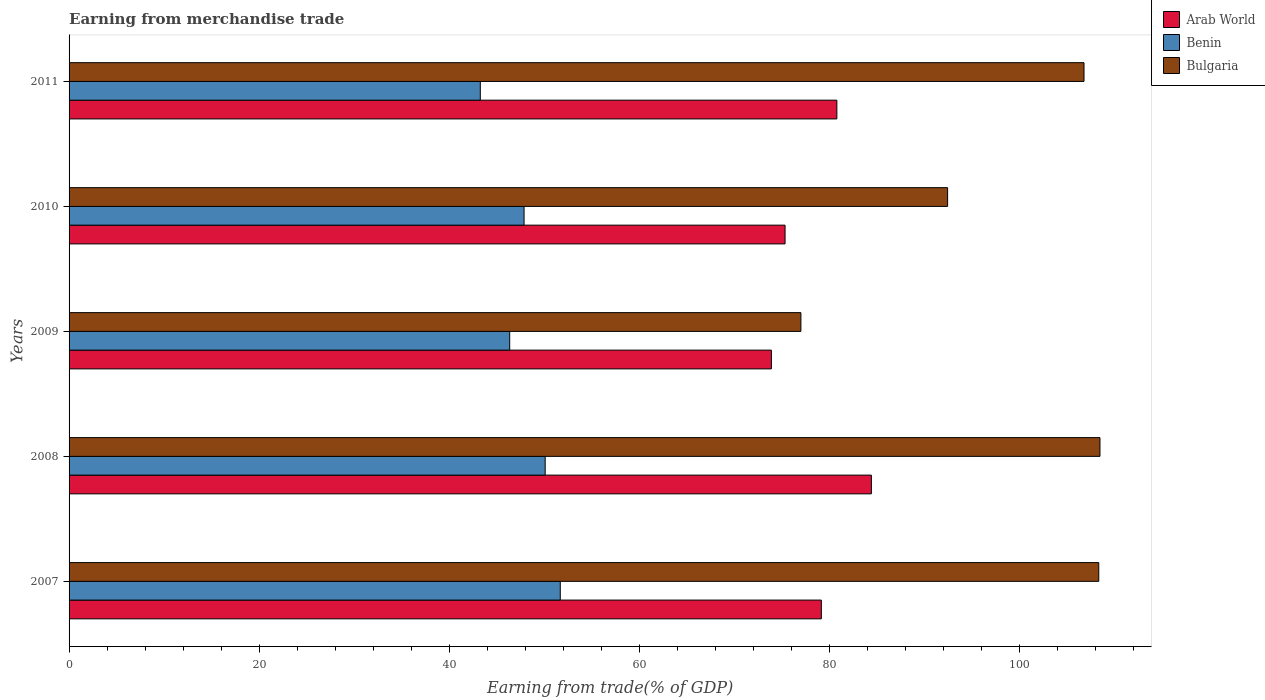How many different coloured bars are there?
Your answer should be compact. 3. How many groups of bars are there?
Offer a very short reply. 5. Are the number of bars per tick equal to the number of legend labels?
Make the answer very short. Yes. Are the number of bars on each tick of the Y-axis equal?
Provide a short and direct response. Yes. What is the label of the 5th group of bars from the top?
Your answer should be very brief. 2007. What is the earnings from trade in Bulgaria in 2010?
Offer a terse response. 92.4. Across all years, what is the maximum earnings from trade in Benin?
Your answer should be compact. 51.66. Across all years, what is the minimum earnings from trade in Arab World?
Offer a terse response. 73.86. What is the total earnings from trade in Benin in the graph?
Your answer should be very brief. 239.18. What is the difference between the earnings from trade in Benin in 2007 and that in 2010?
Make the answer very short. 3.81. What is the difference between the earnings from trade in Benin in 2009 and the earnings from trade in Bulgaria in 2011?
Make the answer very short. -60.4. What is the average earnings from trade in Benin per year?
Offer a very short reply. 47.84. In the year 2011, what is the difference between the earnings from trade in Bulgaria and earnings from trade in Benin?
Provide a succinct answer. 63.49. What is the ratio of the earnings from trade in Bulgaria in 2007 to that in 2009?
Offer a terse response. 1.41. What is the difference between the highest and the second highest earnings from trade in Bulgaria?
Make the answer very short. 0.13. What is the difference between the highest and the lowest earnings from trade in Arab World?
Give a very brief answer. 10.51. Is the sum of the earnings from trade in Bulgaria in 2007 and 2009 greater than the maximum earnings from trade in Arab World across all years?
Make the answer very short. Yes. What does the 1st bar from the top in 2008 represents?
Keep it short and to the point. Bulgaria. What does the 2nd bar from the bottom in 2010 represents?
Keep it short and to the point. Benin. Is it the case that in every year, the sum of the earnings from trade in Benin and earnings from trade in Arab World is greater than the earnings from trade in Bulgaria?
Your response must be concise. Yes. Are all the bars in the graph horizontal?
Ensure brevity in your answer.  Yes. How many years are there in the graph?
Offer a very short reply. 5. Are the values on the major ticks of X-axis written in scientific E-notation?
Provide a short and direct response. No. Does the graph contain grids?
Keep it short and to the point. No. Where does the legend appear in the graph?
Provide a succinct answer. Top right. How are the legend labels stacked?
Your answer should be compact. Vertical. What is the title of the graph?
Ensure brevity in your answer.  Earning from merchandise trade. Does "Middle East & North Africa (all income levels)" appear as one of the legend labels in the graph?
Provide a succinct answer. No. What is the label or title of the X-axis?
Make the answer very short. Earning from trade(% of GDP). What is the Earning from trade(% of GDP) of Arab World in 2007?
Provide a short and direct response. 79.12. What is the Earning from trade(% of GDP) of Benin in 2007?
Offer a terse response. 51.66. What is the Earning from trade(% of GDP) of Bulgaria in 2007?
Ensure brevity in your answer.  108.3. What is the Earning from trade(% of GDP) in Arab World in 2008?
Offer a very short reply. 84.38. What is the Earning from trade(% of GDP) in Benin in 2008?
Ensure brevity in your answer.  50.07. What is the Earning from trade(% of GDP) of Bulgaria in 2008?
Offer a terse response. 108.42. What is the Earning from trade(% of GDP) in Arab World in 2009?
Make the answer very short. 73.86. What is the Earning from trade(% of GDP) in Benin in 2009?
Provide a short and direct response. 46.34. What is the Earning from trade(% of GDP) in Bulgaria in 2009?
Offer a terse response. 76.97. What is the Earning from trade(% of GDP) in Arab World in 2010?
Your response must be concise. 75.3. What is the Earning from trade(% of GDP) of Benin in 2010?
Keep it short and to the point. 47.85. What is the Earning from trade(% of GDP) of Bulgaria in 2010?
Your answer should be compact. 92.4. What is the Earning from trade(% of GDP) in Arab World in 2011?
Ensure brevity in your answer.  80.75. What is the Earning from trade(% of GDP) of Benin in 2011?
Your answer should be very brief. 43.25. What is the Earning from trade(% of GDP) in Bulgaria in 2011?
Your response must be concise. 106.74. Across all years, what is the maximum Earning from trade(% of GDP) in Arab World?
Give a very brief answer. 84.38. Across all years, what is the maximum Earning from trade(% of GDP) of Benin?
Give a very brief answer. 51.66. Across all years, what is the maximum Earning from trade(% of GDP) of Bulgaria?
Provide a short and direct response. 108.42. Across all years, what is the minimum Earning from trade(% of GDP) of Arab World?
Provide a succinct answer. 73.86. Across all years, what is the minimum Earning from trade(% of GDP) of Benin?
Your response must be concise. 43.25. Across all years, what is the minimum Earning from trade(% of GDP) in Bulgaria?
Provide a short and direct response. 76.97. What is the total Earning from trade(% of GDP) of Arab World in the graph?
Provide a succinct answer. 393.41. What is the total Earning from trade(% of GDP) of Benin in the graph?
Offer a terse response. 239.18. What is the total Earning from trade(% of GDP) in Bulgaria in the graph?
Give a very brief answer. 492.83. What is the difference between the Earning from trade(% of GDP) of Arab World in 2007 and that in 2008?
Your response must be concise. -5.26. What is the difference between the Earning from trade(% of GDP) in Benin in 2007 and that in 2008?
Make the answer very short. 1.59. What is the difference between the Earning from trade(% of GDP) in Bulgaria in 2007 and that in 2008?
Your response must be concise. -0.13. What is the difference between the Earning from trade(% of GDP) of Arab World in 2007 and that in 2009?
Offer a very short reply. 5.25. What is the difference between the Earning from trade(% of GDP) in Benin in 2007 and that in 2009?
Your answer should be very brief. 5.32. What is the difference between the Earning from trade(% of GDP) of Bulgaria in 2007 and that in 2009?
Provide a succinct answer. 31.33. What is the difference between the Earning from trade(% of GDP) in Arab World in 2007 and that in 2010?
Offer a terse response. 3.81. What is the difference between the Earning from trade(% of GDP) of Benin in 2007 and that in 2010?
Make the answer very short. 3.81. What is the difference between the Earning from trade(% of GDP) of Bulgaria in 2007 and that in 2010?
Keep it short and to the point. 15.9. What is the difference between the Earning from trade(% of GDP) in Arab World in 2007 and that in 2011?
Provide a short and direct response. -1.63. What is the difference between the Earning from trade(% of GDP) in Benin in 2007 and that in 2011?
Keep it short and to the point. 8.41. What is the difference between the Earning from trade(% of GDP) in Bulgaria in 2007 and that in 2011?
Offer a terse response. 1.55. What is the difference between the Earning from trade(% of GDP) of Arab World in 2008 and that in 2009?
Give a very brief answer. 10.51. What is the difference between the Earning from trade(% of GDP) of Benin in 2008 and that in 2009?
Provide a succinct answer. 3.73. What is the difference between the Earning from trade(% of GDP) of Bulgaria in 2008 and that in 2009?
Your response must be concise. 31.45. What is the difference between the Earning from trade(% of GDP) of Arab World in 2008 and that in 2010?
Your answer should be very brief. 9.08. What is the difference between the Earning from trade(% of GDP) of Benin in 2008 and that in 2010?
Your answer should be very brief. 2.22. What is the difference between the Earning from trade(% of GDP) of Bulgaria in 2008 and that in 2010?
Provide a succinct answer. 16.02. What is the difference between the Earning from trade(% of GDP) of Arab World in 2008 and that in 2011?
Keep it short and to the point. 3.63. What is the difference between the Earning from trade(% of GDP) of Benin in 2008 and that in 2011?
Your response must be concise. 6.82. What is the difference between the Earning from trade(% of GDP) of Bulgaria in 2008 and that in 2011?
Ensure brevity in your answer.  1.68. What is the difference between the Earning from trade(% of GDP) of Arab World in 2009 and that in 2010?
Your answer should be compact. -1.44. What is the difference between the Earning from trade(% of GDP) in Benin in 2009 and that in 2010?
Make the answer very short. -1.51. What is the difference between the Earning from trade(% of GDP) of Bulgaria in 2009 and that in 2010?
Provide a succinct answer. -15.43. What is the difference between the Earning from trade(% of GDP) in Arab World in 2009 and that in 2011?
Offer a terse response. -6.89. What is the difference between the Earning from trade(% of GDP) in Benin in 2009 and that in 2011?
Make the answer very short. 3.09. What is the difference between the Earning from trade(% of GDP) in Bulgaria in 2009 and that in 2011?
Offer a terse response. -29.78. What is the difference between the Earning from trade(% of GDP) in Arab World in 2010 and that in 2011?
Your response must be concise. -5.45. What is the difference between the Earning from trade(% of GDP) of Benin in 2010 and that in 2011?
Your answer should be very brief. 4.6. What is the difference between the Earning from trade(% of GDP) of Bulgaria in 2010 and that in 2011?
Ensure brevity in your answer.  -14.35. What is the difference between the Earning from trade(% of GDP) in Arab World in 2007 and the Earning from trade(% of GDP) in Benin in 2008?
Your answer should be compact. 29.04. What is the difference between the Earning from trade(% of GDP) in Arab World in 2007 and the Earning from trade(% of GDP) in Bulgaria in 2008?
Provide a short and direct response. -29.3. What is the difference between the Earning from trade(% of GDP) in Benin in 2007 and the Earning from trade(% of GDP) in Bulgaria in 2008?
Provide a succinct answer. -56.76. What is the difference between the Earning from trade(% of GDP) of Arab World in 2007 and the Earning from trade(% of GDP) of Benin in 2009?
Provide a short and direct response. 32.78. What is the difference between the Earning from trade(% of GDP) in Arab World in 2007 and the Earning from trade(% of GDP) in Bulgaria in 2009?
Offer a very short reply. 2.15. What is the difference between the Earning from trade(% of GDP) of Benin in 2007 and the Earning from trade(% of GDP) of Bulgaria in 2009?
Keep it short and to the point. -25.31. What is the difference between the Earning from trade(% of GDP) in Arab World in 2007 and the Earning from trade(% of GDP) in Benin in 2010?
Keep it short and to the point. 31.26. What is the difference between the Earning from trade(% of GDP) of Arab World in 2007 and the Earning from trade(% of GDP) of Bulgaria in 2010?
Your answer should be compact. -13.28. What is the difference between the Earning from trade(% of GDP) in Benin in 2007 and the Earning from trade(% of GDP) in Bulgaria in 2010?
Provide a succinct answer. -40.74. What is the difference between the Earning from trade(% of GDP) in Arab World in 2007 and the Earning from trade(% of GDP) in Benin in 2011?
Offer a terse response. 35.87. What is the difference between the Earning from trade(% of GDP) in Arab World in 2007 and the Earning from trade(% of GDP) in Bulgaria in 2011?
Your answer should be compact. -27.63. What is the difference between the Earning from trade(% of GDP) of Benin in 2007 and the Earning from trade(% of GDP) of Bulgaria in 2011?
Give a very brief answer. -55.08. What is the difference between the Earning from trade(% of GDP) in Arab World in 2008 and the Earning from trade(% of GDP) in Benin in 2009?
Provide a succinct answer. 38.04. What is the difference between the Earning from trade(% of GDP) in Arab World in 2008 and the Earning from trade(% of GDP) in Bulgaria in 2009?
Make the answer very short. 7.41. What is the difference between the Earning from trade(% of GDP) in Benin in 2008 and the Earning from trade(% of GDP) in Bulgaria in 2009?
Provide a short and direct response. -26.9. What is the difference between the Earning from trade(% of GDP) in Arab World in 2008 and the Earning from trade(% of GDP) in Benin in 2010?
Your answer should be very brief. 36.53. What is the difference between the Earning from trade(% of GDP) of Arab World in 2008 and the Earning from trade(% of GDP) of Bulgaria in 2010?
Your answer should be compact. -8.02. What is the difference between the Earning from trade(% of GDP) of Benin in 2008 and the Earning from trade(% of GDP) of Bulgaria in 2010?
Your response must be concise. -42.33. What is the difference between the Earning from trade(% of GDP) in Arab World in 2008 and the Earning from trade(% of GDP) in Benin in 2011?
Provide a succinct answer. 41.13. What is the difference between the Earning from trade(% of GDP) in Arab World in 2008 and the Earning from trade(% of GDP) in Bulgaria in 2011?
Provide a succinct answer. -22.36. What is the difference between the Earning from trade(% of GDP) of Benin in 2008 and the Earning from trade(% of GDP) of Bulgaria in 2011?
Your response must be concise. -56.67. What is the difference between the Earning from trade(% of GDP) of Arab World in 2009 and the Earning from trade(% of GDP) of Benin in 2010?
Offer a terse response. 26.01. What is the difference between the Earning from trade(% of GDP) in Arab World in 2009 and the Earning from trade(% of GDP) in Bulgaria in 2010?
Your answer should be very brief. -18.53. What is the difference between the Earning from trade(% of GDP) of Benin in 2009 and the Earning from trade(% of GDP) of Bulgaria in 2010?
Offer a very short reply. -46.06. What is the difference between the Earning from trade(% of GDP) of Arab World in 2009 and the Earning from trade(% of GDP) of Benin in 2011?
Your answer should be very brief. 30.62. What is the difference between the Earning from trade(% of GDP) in Arab World in 2009 and the Earning from trade(% of GDP) in Bulgaria in 2011?
Provide a succinct answer. -32.88. What is the difference between the Earning from trade(% of GDP) of Benin in 2009 and the Earning from trade(% of GDP) of Bulgaria in 2011?
Ensure brevity in your answer.  -60.4. What is the difference between the Earning from trade(% of GDP) of Arab World in 2010 and the Earning from trade(% of GDP) of Benin in 2011?
Offer a very short reply. 32.05. What is the difference between the Earning from trade(% of GDP) in Arab World in 2010 and the Earning from trade(% of GDP) in Bulgaria in 2011?
Keep it short and to the point. -31.44. What is the difference between the Earning from trade(% of GDP) in Benin in 2010 and the Earning from trade(% of GDP) in Bulgaria in 2011?
Your answer should be very brief. -58.89. What is the average Earning from trade(% of GDP) in Arab World per year?
Provide a succinct answer. 78.68. What is the average Earning from trade(% of GDP) in Benin per year?
Keep it short and to the point. 47.84. What is the average Earning from trade(% of GDP) of Bulgaria per year?
Your answer should be very brief. 98.57. In the year 2007, what is the difference between the Earning from trade(% of GDP) in Arab World and Earning from trade(% of GDP) in Benin?
Offer a terse response. 27.46. In the year 2007, what is the difference between the Earning from trade(% of GDP) in Arab World and Earning from trade(% of GDP) in Bulgaria?
Ensure brevity in your answer.  -29.18. In the year 2007, what is the difference between the Earning from trade(% of GDP) of Benin and Earning from trade(% of GDP) of Bulgaria?
Give a very brief answer. -56.64. In the year 2008, what is the difference between the Earning from trade(% of GDP) of Arab World and Earning from trade(% of GDP) of Benin?
Offer a very short reply. 34.31. In the year 2008, what is the difference between the Earning from trade(% of GDP) of Arab World and Earning from trade(% of GDP) of Bulgaria?
Your answer should be compact. -24.04. In the year 2008, what is the difference between the Earning from trade(% of GDP) in Benin and Earning from trade(% of GDP) in Bulgaria?
Make the answer very short. -58.35. In the year 2009, what is the difference between the Earning from trade(% of GDP) in Arab World and Earning from trade(% of GDP) in Benin?
Your response must be concise. 27.52. In the year 2009, what is the difference between the Earning from trade(% of GDP) of Arab World and Earning from trade(% of GDP) of Bulgaria?
Offer a terse response. -3.1. In the year 2009, what is the difference between the Earning from trade(% of GDP) of Benin and Earning from trade(% of GDP) of Bulgaria?
Provide a succinct answer. -30.63. In the year 2010, what is the difference between the Earning from trade(% of GDP) of Arab World and Earning from trade(% of GDP) of Benin?
Keep it short and to the point. 27.45. In the year 2010, what is the difference between the Earning from trade(% of GDP) in Arab World and Earning from trade(% of GDP) in Bulgaria?
Provide a succinct answer. -17.1. In the year 2010, what is the difference between the Earning from trade(% of GDP) of Benin and Earning from trade(% of GDP) of Bulgaria?
Your answer should be compact. -44.55. In the year 2011, what is the difference between the Earning from trade(% of GDP) of Arab World and Earning from trade(% of GDP) of Benin?
Offer a very short reply. 37.5. In the year 2011, what is the difference between the Earning from trade(% of GDP) of Arab World and Earning from trade(% of GDP) of Bulgaria?
Offer a very short reply. -25.99. In the year 2011, what is the difference between the Earning from trade(% of GDP) of Benin and Earning from trade(% of GDP) of Bulgaria?
Provide a succinct answer. -63.49. What is the ratio of the Earning from trade(% of GDP) of Arab World in 2007 to that in 2008?
Your answer should be compact. 0.94. What is the ratio of the Earning from trade(% of GDP) of Benin in 2007 to that in 2008?
Provide a succinct answer. 1.03. What is the ratio of the Earning from trade(% of GDP) of Arab World in 2007 to that in 2009?
Keep it short and to the point. 1.07. What is the ratio of the Earning from trade(% of GDP) of Benin in 2007 to that in 2009?
Your response must be concise. 1.11. What is the ratio of the Earning from trade(% of GDP) in Bulgaria in 2007 to that in 2009?
Provide a succinct answer. 1.41. What is the ratio of the Earning from trade(% of GDP) of Arab World in 2007 to that in 2010?
Keep it short and to the point. 1.05. What is the ratio of the Earning from trade(% of GDP) in Benin in 2007 to that in 2010?
Ensure brevity in your answer.  1.08. What is the ratio of the Earning from trade(% of GDP) of Bulgaria in 2007 to that in 2010?
Ensure brevity in your answer.  1.17. What is the ratio of the Earning from trade(% of GDP) of Arab World in 2007 to that in 2011?
Your answer should be compact. 0.98. What is the ratio of the Earning from trade(% of GDP) in Benin in 2007 to that in 2011?
Make the answer very short. 1.19. What is the ratio of the Earning from trade(% of GDP) of Bulgaria in 2007 to that in 2011?
Your response must be concise. 1.01. What is the ratio of the Earning from trade(% of GDP) of Arab World in 2008 to that in 2009?
Offer a terse response. 1.14. What is the ratio of the Earning from trade(% of GDP) in Benin in 2008 to that in 2009?
Provide a succinct answer. 1.08. What is the ratio of the Earning from trade(% of GDP) of Bulgaria in 2008 to that in 2009?
Provide a short and direct response. 1.41. What is the ratio of the Earning from trade(% of GDP) of Arab World in 2008 to that in 2010?
Keep it short and to the point. 1.12. What is the ratio of the Earning from trade(% of GDP) of Benin in 2008 to that in 2010?
Keep it short and to the point. 1.05. What is the ratio of the Earning from trade(% of GDP) in Bulgaria in 2008 to that in 2010?
Provide a short and direct response. 1.17. What is the ratio of the Earning from trade(% of GDP) of Arab World in 2008 to that in 2011?
Make the answer very short. 1.04. What is the ratio of the Earning from trade(% of GDP) of Benin in 2008 to that in 2011?
Give a very brief answer. 1.16. What is the ratio of the Earning from trade(% of GDP) of Bulgaria in 2008 to that in 2011?
Keep it short and to the point. 1.02. What is the ratio of the Earning from trade(% of GDP) of Arab World in 2009 to that in 2010?
Keep it short and to the point. 0.98. What is the ratio of the Earning from trade(% of GDP) of Benin in 2009 to that in 2010?
Make the answer very short. 0.97. What is the ratio of the Earning from trade(% of GDP) of Bulgaria in 2009 to that in 2010?
Give a very brief answer. 0.83. What is the ratio of the Earning from trade(% of GDP) of Arab World in 2009 to that in 2011?
Keep it short and to the point. 0.91. What is the ratio of the Earning from trade(% of GDP) of Benin in 2009 to that in 2011?
Provide a short and direct response. 1.07. What is the ratio of the Earning from trade(% of GDP) of Bulgaria in 2009 to that in 2011?
Your answer should be very brief. 0.72. What is the ratio of the Earning from trade(% of GDP) of Arab World in 2010 to that in 2011?
Your answer should be very brief. 0.93. What is the ratio of the Earning from trade(% of GDP) in Benin in 2010 to that in 2011?
Provide a succinct answer. 1.11. What is the ratio of the Earning from trade(% of GDP) in Bulgaria in 2010 to that in 2011?
Ensure brevity in your answer.  0.87. What is the difference between the highest and the second highest Earning from trade(% of GDP) of Arab World?
Offer a very short reply. 3.63. What is the difference between the highest and the second highest Earning from trade(% of GDP) of Benin?
Give a very brief answer. 1.59. What is the difference between the highest and the second highest Earning from trade(% of GDP) of Bulgaria?
Give a very brief answer. 0.13. What is the difference between the highest and the lowest Earning from trade(% of GDP) in Arab World?
Your answer should be very brief. 10.51. What is the difference between the highest and the lowest Earning from trade(% of GDP) of Benin?
Offer a terse response. 8.41. What is the difference between the highest and the lowest Earning from trade(% of GDP) of Bulgaria?
Give a very brief answer. 31.45. 